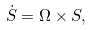Convert formula to latex. <formula><loc_0><loc_0><loc_500><loc_500>\dot { S } = \Omega \times S ,</formula> 